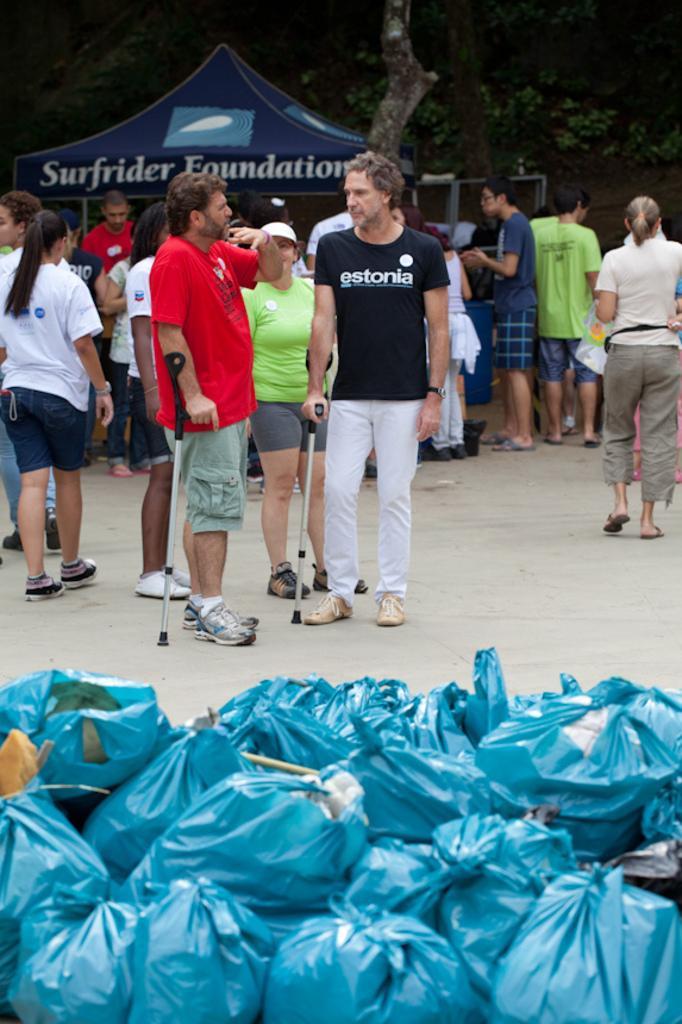Please provide a concise description of this image. In this image we can see some people and cover bags on the floor, in the background, we can see a tent and some trees. 